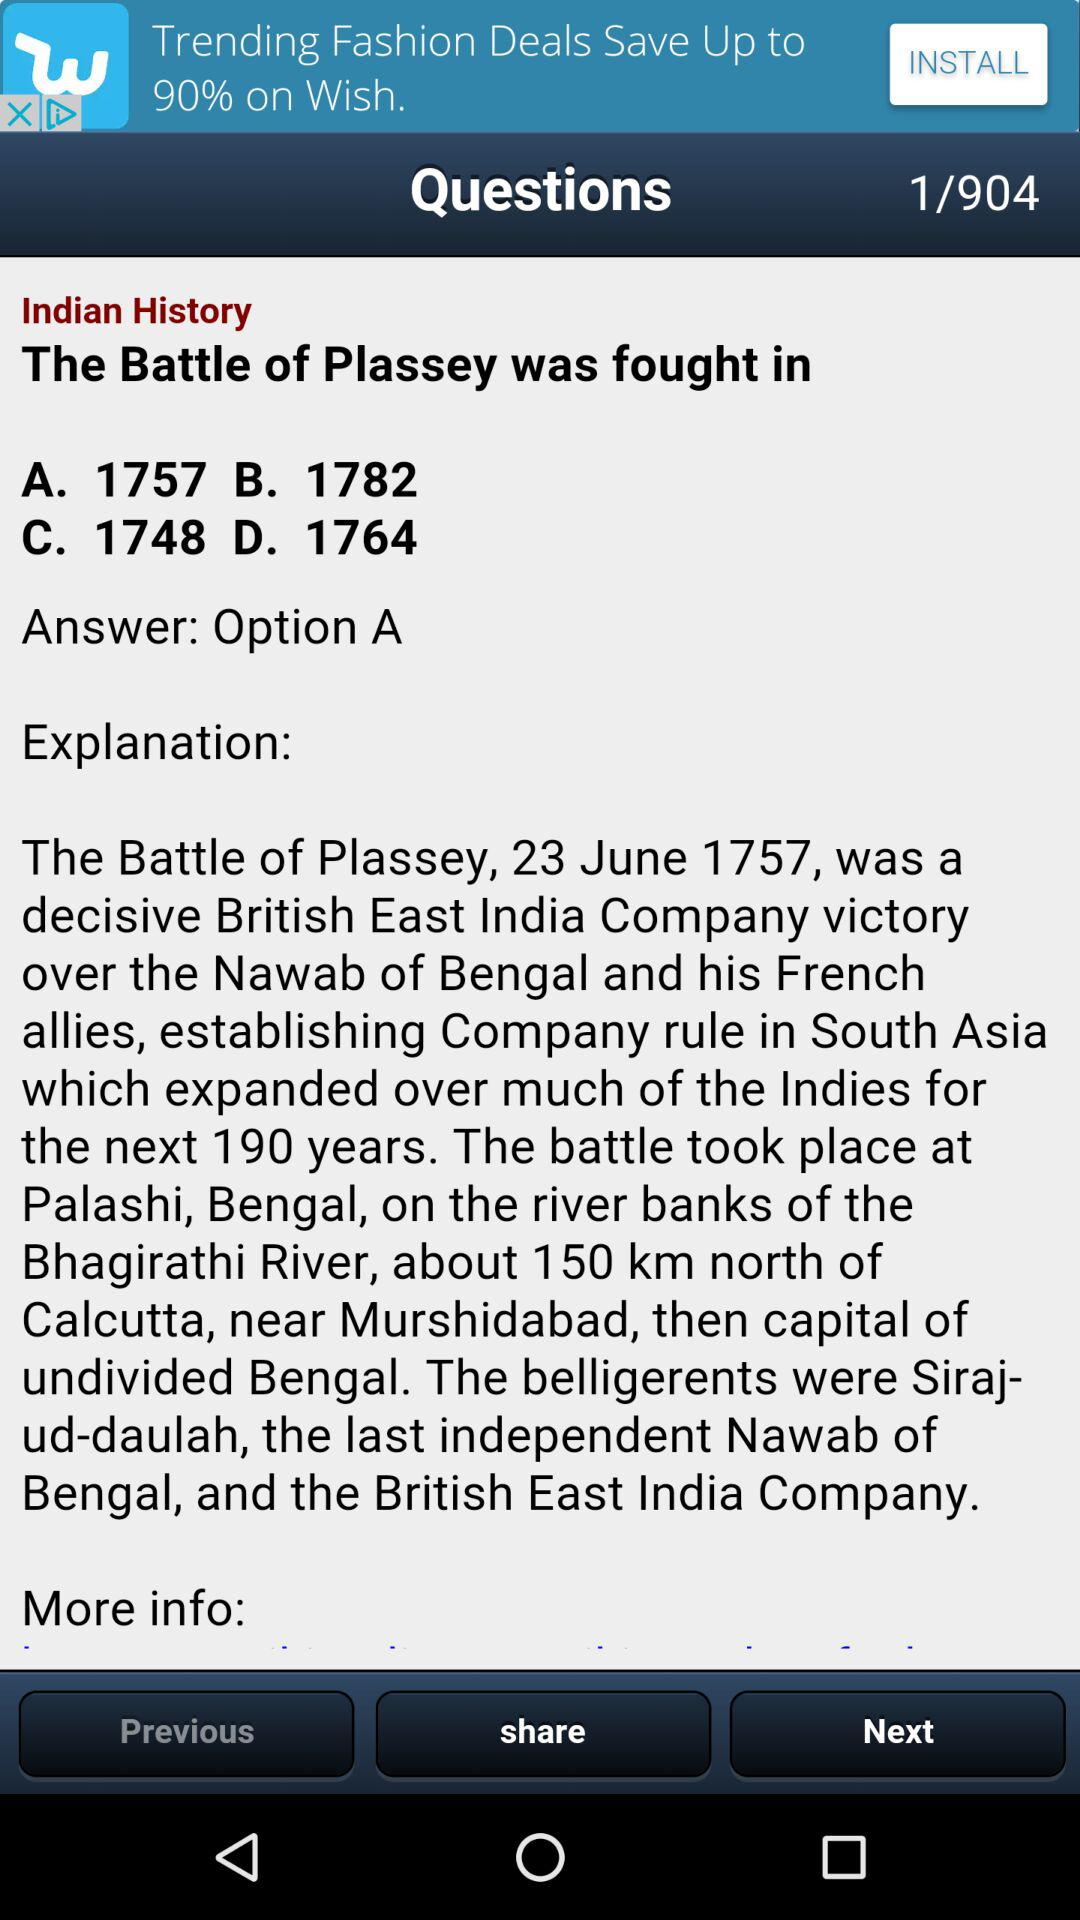Which option is mentioned as the answer? The option that is mentioned as the answer is "A". 